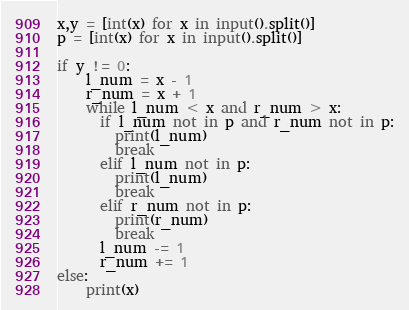Convert code to text. <code><loc_0><loc_0><loc_500><loc_500><_Python_>x,y = [int(x) for x in input().split()]
p = [int(x) for x in input().split()] 

if y != 0: 
    l_num = x - 1
    r_num = x + 1 
    while l_num < x and r_num > x:
      if l_num not in p and r_num not in p:
        print(l_num)
        break
      elif l_num not in p:
        print(l_num)
        break
      elif r_num not in p:
        print(r_num)
        break
      l_num -= 1
      r_num += 1
else:
    print(x)

</code> 